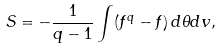<formula> <loc_0><loc_0><loc_500><loc_500>S = - \frac { 1 } { q - 1 } \int ( f ^ { q } - f ) \, d \theta d v ,</formula> 